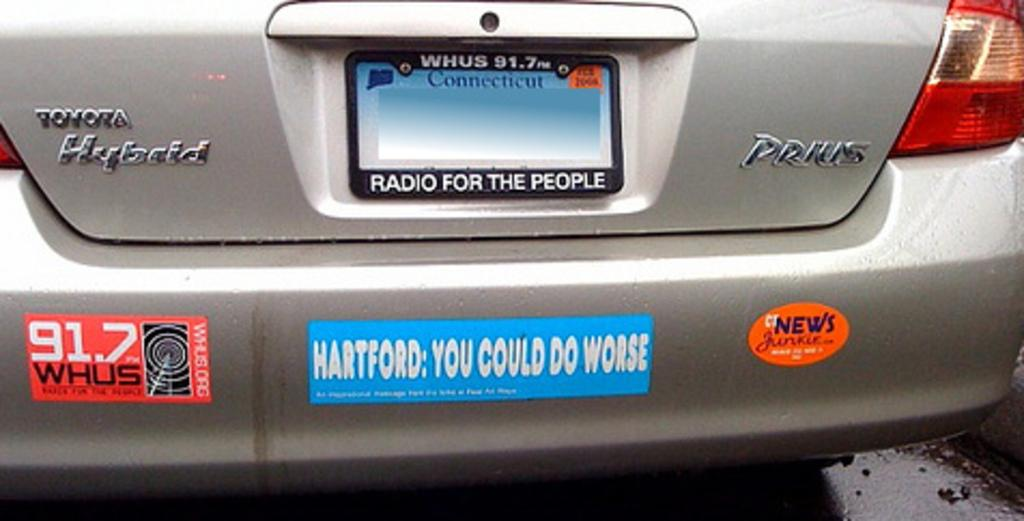<image>
Create a compact narrative representing the image presented. a sign on the back of a car that says Hartford on it 